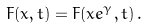Convert formula to latex. <formula><loc_0><loc_0><loc_500><loc_500>F ( x , t ) = F ( x e ^ { \gamma } , t ) \, .</formula> 